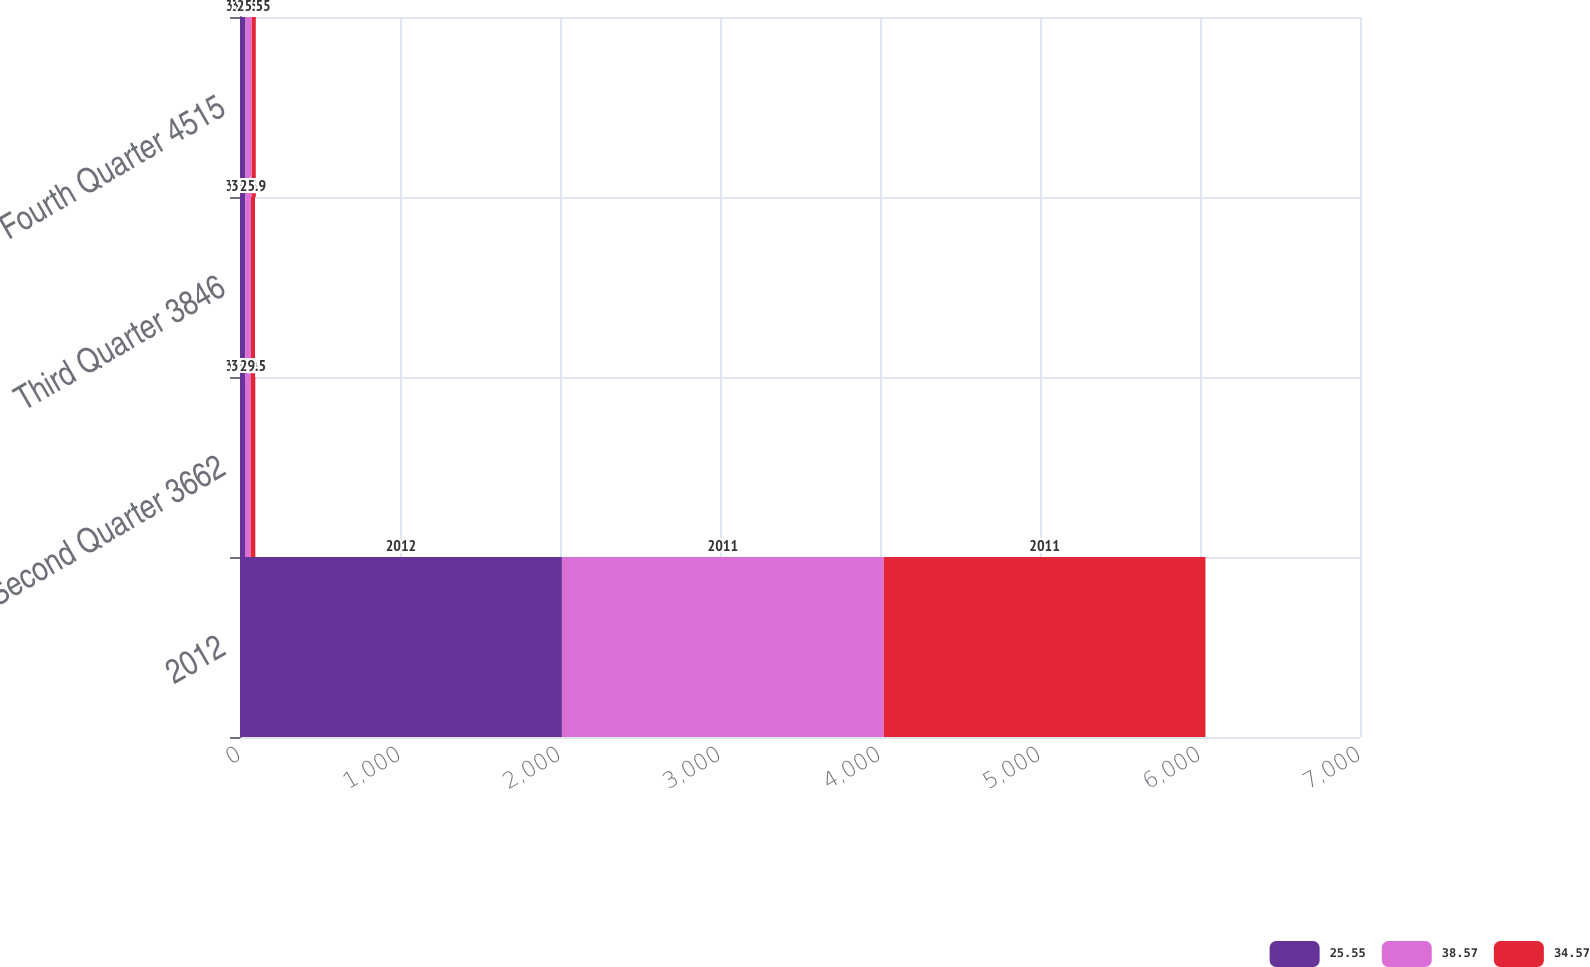<chart> <loc_0><loc_0><loc_500><loc_500><stacked_bar_chart><ecel><fcel>2012<fcel>Second Quarter 3662<fcel>Third Quarter 3846<fcel>Fourth Quarter 4515<nl><fcel>25.55<fcel>2012<fcel>31.29<fcel>32.69<fcel>34.57<nl><fcel>38.57<fcel>2011<fcel>35.04<fcel>35.31<fcel>38.57<nl><fcel>34.57<fcel>2011<fcel>29.5<fcel>25.9<fcel>25.55<nl></chart> 